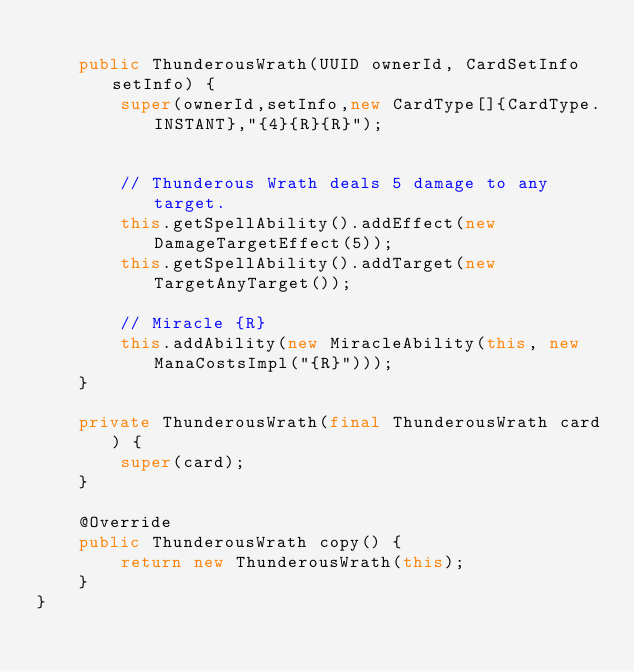Convert code to text. <code><loc_0><loc_0><loc_500><loc_500><_Java_>
    public ThunderousWrath(UUID ownerId, CardSetInfo setInfo) {
        super(ownerId,setInfo,new CardType[]{CardType.INSTANT},"{4}{R}{R}");


        // Thunderous Wrath deals 5 damage to any target.
        this.getSpellAbility().addEffect(new DamageTargetEffect(5));
        this.getSpellAbility().addTarget(new TargetAnyTarget());

        // Miracle {R}
        this.addAbility(new MiracleAbility(this, new ManaCostsImpl("{R}")));
    }

    private ThunderousWrath(final ThunderousWrath card) {
        super(card);
    }

    @Override
    public ThunderousWrath copy() {
        return new ThunderousWrath(this);
    }
}
</code> 